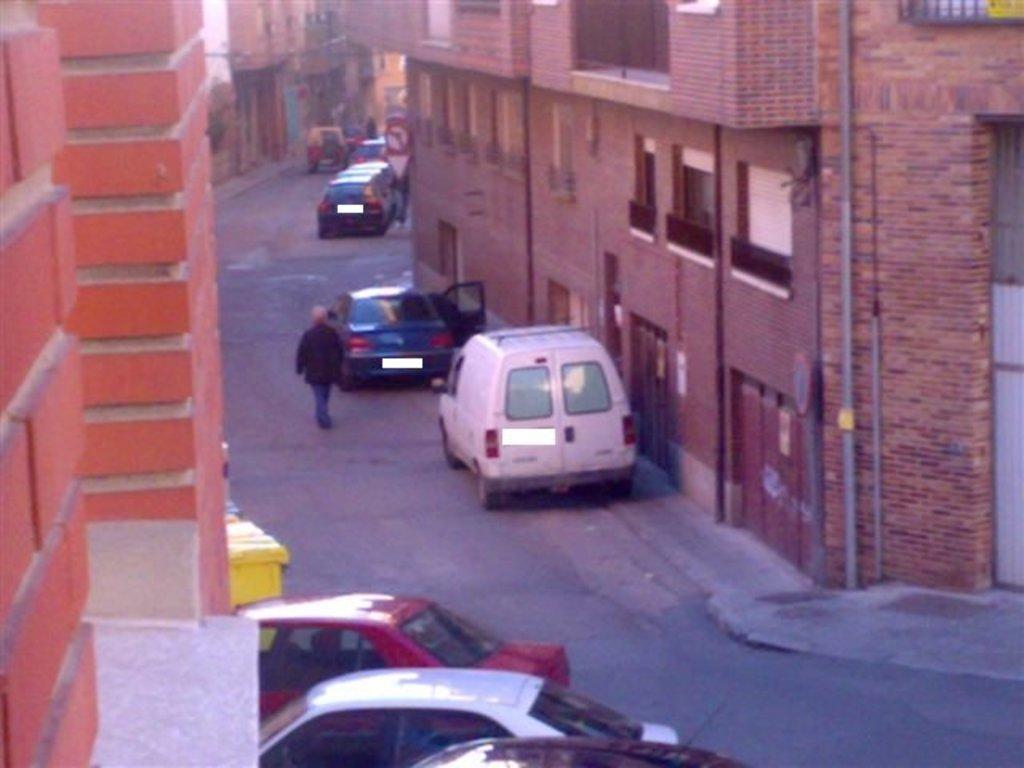In one or two sentences, can you explain what this image depicts? In this image I can see the road, few vehicles on the road, a person wearing black and blue colored dress is standing on the road, few buildings on both sides of the road which are brown in color and few windows of the building. 